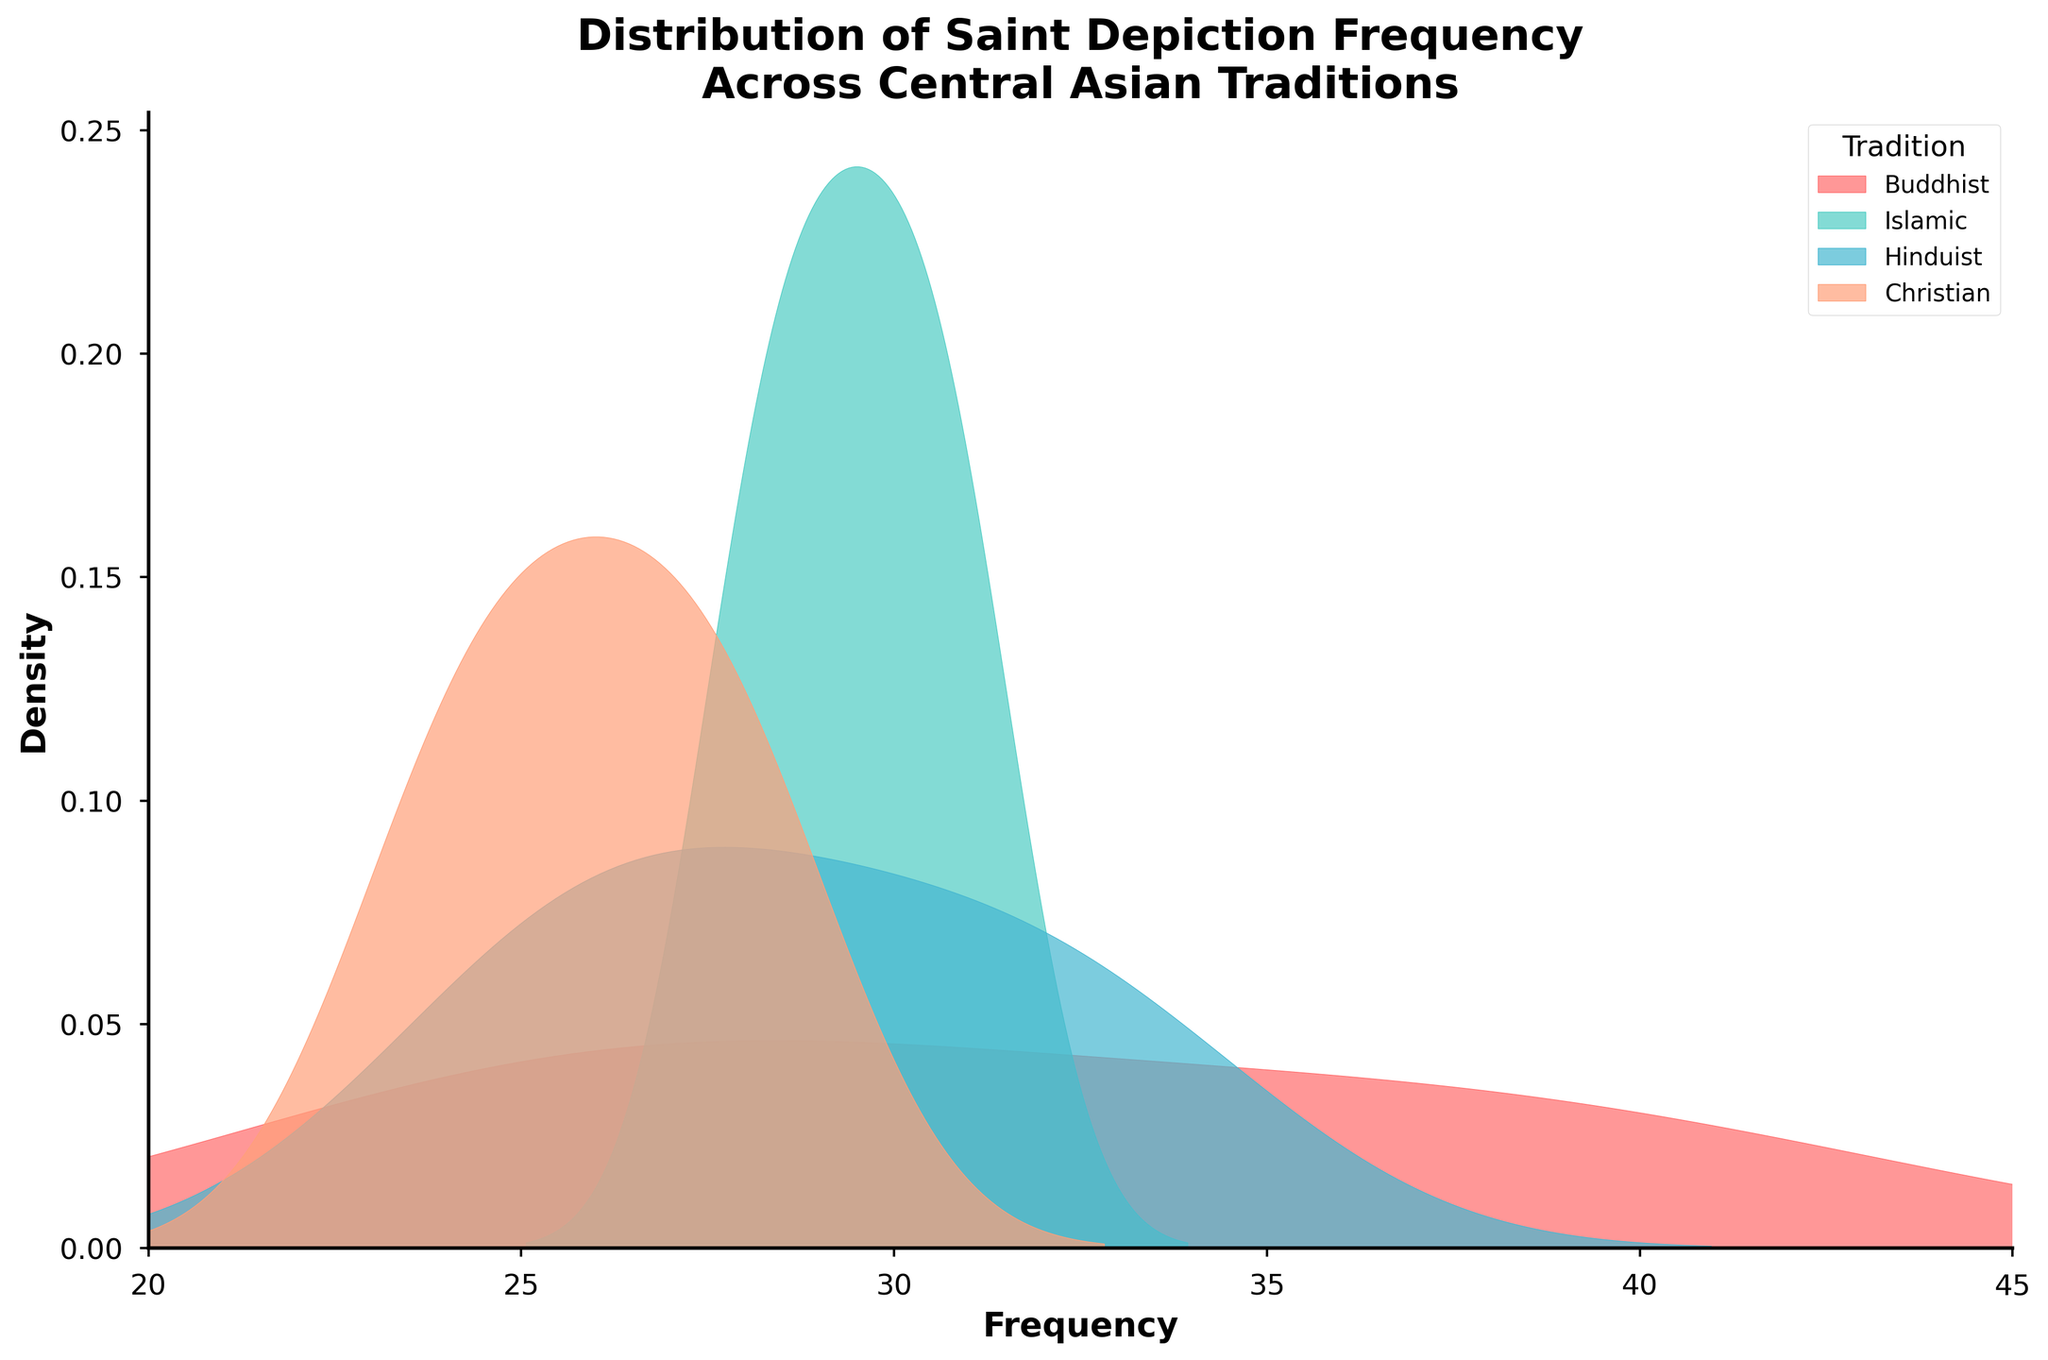What is the title of the figure? The title is usually positioned at the top of the figure. Here, it states "Distribution of Saint Depiction Frequency Across Central Asian Traditions".
Answer: Distribution of Saint Depiction Frequency Across Central Asian Traditions What does the x-axis represent? The x-axis label is found along the horizontal axis and it indicates the range of values being measured. In this case, the label reads "Frequency".
Answer: Frequency Which tradition has a color band associated with green and has a peak around 30? The legend distinguishes different traditions by their colors. The green-colored band corresponds to the "Hinduist" tradition, and the peak around 30 is also associated with this tradition.
Answer: Hinduist What is the estimated peak frequency for the Buddhist tradition? Refer to the color label for Buddhist in the legend. Identify and observe the respective curve’s highest point on the x-axis, around 40.
Answer: Around 40 How many traditions are depicted in the figure? By observing the legend, we can count the distinct names listed. There are four distinct traditions: Buddhist, Islamic, Hinduist, and Christian.
Answer: Four Which tradition shows the widest range in its frequency distribution? Look for the distribution that spans the largest interval along the x-axis. The curve for the "Islamic" tradition appears broader than the others.
Answer: Islamic Compare the peaks of the Christian and Islamic traditions. Which has a higher peak? Identify the respective colored curves for Christian (probably red) and Islamic (likely green) and compare their peak heights on the density scale. The Christian tradition has a higher peak around 28.
Answer: Christian What is the approximate maximum density value for the Islamic tradition? Locate the peak of the Islamic (green) curve and estimate its height on the y-axis representing density. It’s approximately between 0.05 and 0.07.
Answer: 0.06 Does the Buddhist tradition have a higher peak density value than the Hinduist tradition? Compare the peak heights of the Buddhist (likely blue) and Hinduist (possibly green) curves on the density scale. The Buddhist peak is slightly higher.
Answer: Yes Within the range of 25 to 30 frequencies, which traditions show significant depiction frequency? Identify the curves passing through the 25 to 30 range on the x-axis. All traditions—Buddhist, Islamic, Hinduist, and Christian—show significant depiction frequencies in this range.
Answer: All 